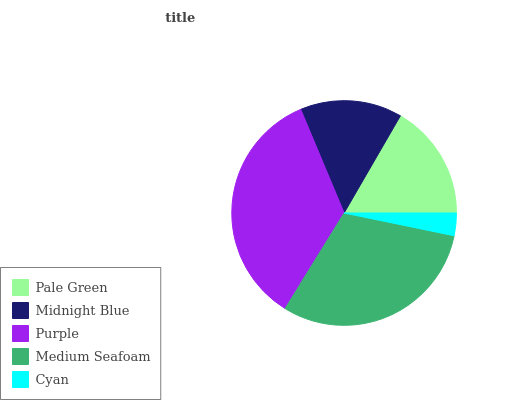Is Cyan the minimum?
Answer yes or no. Yes. Is Purple the maximum?
Answer yes or no. Yes. Is Midnight Blue the minimum?
Answer yes or no. No. Is Midnight Blue the maximum?
Answer yes or no. No. Is Pale Green greater than Midnight Blue?
Answer yes or no. Yes. Is Midnight Blue less than Pale Green?
Answer yes or no. Yes. Is Midnight Blue greater than Pale Green?
Answer yes or no. No. Is Pale Green less than Midnight Blue?
Answer yes or no. No. Is Pale Green the high median?
Answer yes or no. Yes. Is Pale Green the low median?
Answer yes or no. Yes. Is Midnight Blue the high median?
Answer yes or no. No. Is Medium Seafoam the low median?
Answer yes or no. No. 